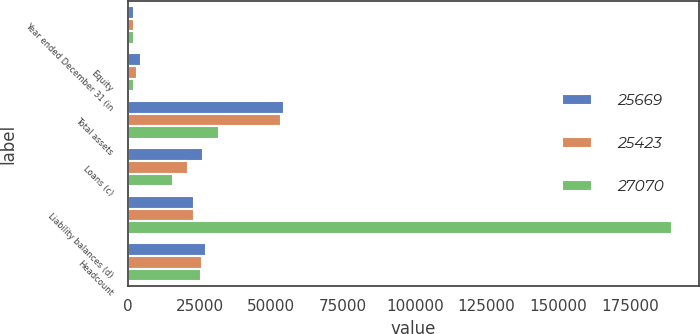Convert chart to OTSL. <chart><loc_0><loc_0><loc_500><loc_500><stacked_bar_chart><ecel><fcel>Year ended December 31 (in<fcel>Equity<fcel>Total assets<fcel>Loans (c)<fcel>Liability balances (d)<fcel>Headcount<nl><fcel>25669<fcel>2008<fcel>4500<fcel>54563<fcel>26226<fcel>23122<fcel>27070<nl><fcel>25423<fcel>2007<fcel>3000<fcel>53350<fcel>20821<fcel>23122<fcel>25669<nl><fcel>27070<fcel>2006<fcel>2200<fcel>31760<fcel>15564<fcel>189540<fcel>25423<nl></chart> 